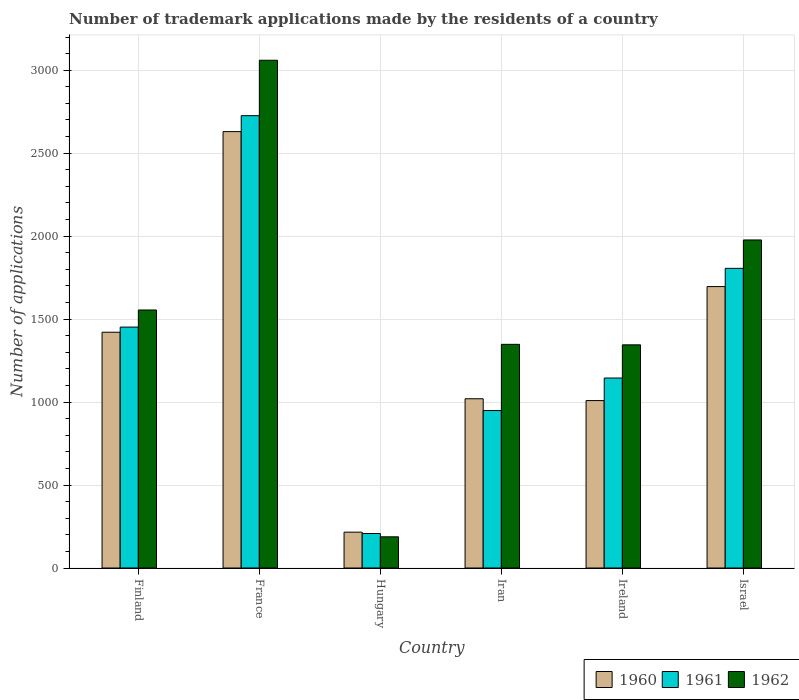How many different coloured bars are there?
Your answer should be compact. 3. Are the number of bars per tick equal to the number of legend labels?
Your answer should be compact. Yes. Are the number of bars on each tick of the X-axis equal?
Offer a terse response. Yes. How many bars are there on the 6th tick from the left?
Provide a short and direct response. 3. What is the label of the 3rd group of bars from the left?
Provide a succinct answer. Hungary. What is the number of trademark applications made by the residents in 1960 in France?
Your response must be concise. 2630. Across all countries, what is the maximum number of trademark applications made by the residents in 1962?
Offer a terse response. 3060. Across all countries, what is the minimum number of trademark applications made by the residents in 1960?
Provide a succinct answer. 216. In which country was the number of trademark applications made by the residents in 1962 minimum?
Your answer should be very brief. Hungary. What is the total number of trademark applications made by the residents in 1960 in the graph?
Your answer should be compact. 7992. What is the difference between the number of trademark applications made by the residents in 1962 in France and that in Ireland?
Offer a terse response. 1715. What is the difference between the number of trademark applications made by the residents in 1961 in Ireland and the number of trademark applications made by the residents in 1962 in Hungary?
Provide a short and direct response. 957. What is the average number of trademark applications made by the residents in 1962 per country?
Provide a succinct answer. 1578.83. What is the difference between the number of trademark applications made by the residents of/in 1960 and number of trademark applications made by the residents of/in 1962 in Ireland?
Ensure brevity in your answer.  -336. In how many countries, is the number of trademark applications made by the residents in 1960 greater than 800?
Your answer should be compact. 5. What is the ratio of the number of trademark applications made by the residents in 1961 in France to that in Iran?
Your answer should be very brief. 2.87. Is the difference between the number of trademark applications made by the residents in 1960 in France and Israel greater than the difference between the number of trademark applications made by the residents in 1962 in France and Israel?
Provide a succinct answer. No. What is the difference between the highest and the second highest number of trademark applications made by the residents in 1962?
Provide a succinct answer. 422. What is the difference between the highest and the lowest number of trademark applications made by the residents in 1962?
Provide a short and direct response. 2872. Is the sum of the number of trademark applications made by the residents in 1962 in Finland and Iran greater than the maximum number of trademark applications made by the residents in 1961 across all countries?
Keep it short and to the point. Yes. What does the 1st bar from the right in France represents?
Ensure brevity in your answer.  1962. How many countries are there in the graph?
Provide a short and direct response. 6. What is the title of the graph?
Your response must be concise. Number of trademark applications made by the residents of a country. Does "1980" appear as one of the legend labels in the graph?
Provide a short and direct response. No. What is the label or title of the Y-axis?
Make the answer very short. Number of applications. What is the Number of applications in 1960 in Finland?
Your answer should be compact. 1421. What is the Number of applications in 1961 in Finland?
Your response must be concise. 1452. What is the Number of applications of 1962 in Finland?
Provide a succinct answer. 1555. What is the Number of applications in 1960 in France?
Make the answer very short. 2630. What is the Number of applications in 1961 in France?
Provide a succinct answer. 2726. What is the Number of applications in 1962 in France?
Ensure brevity in your answer.  3060. What is the Number of applications of 1960 in Hungary?
Provide a short and direct response. 216. What is the Number of applications in 1961 in Hungary?
Offer a terse response. 208. What is the Number of applications of 1962 in Hungary?
Keep it short and to the point. 188. What is the Number of applications in 1960 in Iran?
Provide a short and direct response. 1020. What is the Number of applications of 1961 in Iran?
Your answer should be very brief. 949. What is the Number of applications of 1962 in Iran?
Keep it short and to the point. 1348. What is the Number of applications of 1960 in Ireland?
Offer a very short reply. 1009. What is the Number of applications of 1961 in Ireland?
Offer a terse response. 1145. What is the Number of applications of 1962 in Ireland?
Make the answer very short. 1345. What is the Number of applications of 1960 in Israel?
Offer a very short reply. 1696. What is the Number of applications of 1961 in Israel?
Your answer should be compact. 1806. What is the Number of applications in 1962 in Israel?
Provide a short and direct response. 1977. Across all countries, what is the maximum Number of applications in 1960?
Your answer should be compact. 2630. Across all countries, what is the maximum Number of applications in 1961?
Give a very brief answer. 2726. Across all countries, what is the maximum Number of applications of 1962?
Your answer should be compact. 3060. Across all countries, what is the minimum Number of applications in 1960?
Make the answer very short. 216. Across all countries, what is the minimum Number of applications of 1961?
Offer a terse response. 208. Across all countries, what is the minimum Number of applications in 1962?
Give a very brief answer. 188. What is the total Number of applications in 1960 in the graph?
Make the answer very short. 7992. What is the total Number of applications of 1961 in the graph?
Offer a very short reply. 8286. What is the total Number of applications in 1962 in the graph?
Ensure brevity in your answer.  9473. What is the difference between the Number of applications of 1960 in Finland and that in France?
Offer a terse response. -1209. What is the difference between the Number of applications of 1961 in Finland and that in France?
Provide a succinct answer. -1274. What is the difference between the Number of applications of 1962 in Finland and that in France?
Keep it short and to the point. -1505. What is the difference between the Number of applications of 1960 in Finland and that in Hungary?
Keep it short and to the point. 1205. What is the difference between the Number of applications of 1961 in Finland and that in Hungary?
Give a very brief answer. 1244. What is the difference between the Number of applications of 1962 in Finland and that in Hungary?
Offer a very short reply. 1367. What is the difference between the Number of applications of 1960 in Finland and that in Iran?
Ensure brevity in your answer.  401. What is the difference between the Number of applications of 1961 in Finland and that in Iran?
Your answer should be very brief. 503. What is the difference between the Number of applications in 1962 in Finland and that in Iran?
Offer a terse response. 207. What is the difference between the Number of applications of 1960 in Finland and that in Ireland?
Make the answer very short. 412. What is the difference between the Number of applications in 1961 in Finland and that in Ireland?
Ensure brevity in your answer.  307. What is the difference between the Number of applications of 1962 in Finland and that in Ireland?
Keep it short and to the point. 210. What is the difference between the Number of applications of 1960 in Finland and that in Israel?
Provide a succinct answer. -275. What is the difference between the Number of applications in 1961 in Finland and that in Israel?
Your answer should be very brief. -354. What is the difference between the Number of applications of 1962 in Finland and that in Israel?
Your response must be concise. -422. What is the difference between the Number of applications in 1960 in France and that in Hungary?
Keep it short and to the point. 2414. What is the difference between the Number of applications in 1961 in France and that in Hungary?
Offer a terse response. 2518. What is the difference between the Number of applications in 1962 in France and that in Hungary?
Keep it short and to the point. 2872. What is the difference between the Number of applications in 1960 in France and that in Iran?
Give a very brief answer. 1610. What is the difference between the Number of applications of 1961 in France and that in Iran?
Provide a succinct answer. 1777. What is the difference between the Number of applications of 1962 in France and that in Iran?
Keep it short and to the point. 1712. What is the difference between the Number of applications of 1960 in France and that in Ireland?
Your response must be concise. 1621. What is the difference between the Number of applications of 1961 in France and that in Ireland?
Give a very brief answer. 1581. What is the difference between the Number of applications in 1962 in France and that in Ireland?
Provide a succinct answer. 1715. What is the difference between the Number of applications of 1960 in France and that in Israel?
Ensure brevity in your answer.  934. What is the difference between the Number of applications of 1961 in France and that in Israel?
Offer a terse response. 920. What is the difference between the Number of applications of 1962 in France and that in Israel?
Provide a short and direct response. 1083. What is the difference between the Number of applications in 1960 in Hungary and that in Iran?
Your answer should be compact. -804. What is the difference between the Number of applications of 1961 in Hungary and that in Iran?
Offer a terse response. -741. What is the difference between the Number of applications of 1962 in Hungary and that in Iran?
Your answer should be very brief. -1160. What is the difference between the Number of applications in 1960 in Hungary and that in Ireland?
Make the answer very short. -793. What is the difference between the Number of applications of 1961 in Hungary and that in Ireland?
Give a very brief answer. -937. What is the difference between the Number of applications in 1962 in Hungary and that in Ireland?
Provide a succinct answer. -1157. What is the difference between the Number of applications of 1960 in Hungary and that in Israel?
Give a very brief answer. -1480. What is the difference between the Number of applications of 1961 in Hungary and that in Israel?
Provide a short and direct response. -1598. What is the difference between the Number of applications in 1962 in Hungary and that in Israel?
Make the answer very short. -1789. What is the difference between the Number of applications of 1960 in Iran and that in Ireland?
Your response must be concise. 11. What is the difference between the Number of applications in 1961 in Iran and that in Ireland?
Offer a very short reply. -196. What is the difference between the Number of applications in 1960 in Iran and that in Israel?
Offer a terse response. -676. What is the difference between the Number of applications in 1961 in Iran and that in Israel?
Your answer should be compact. -857. What is the difference between the Number of applications of 1962 in Iran and that in Israel?
Your answer should be very brief. -629. What is the difference between the Number of applications in 1960 in Ireland and that in Israel?
Your answer should be compact. -687. What is the difference between the Number of applications of 1961 in Ireland and that in Israel?
Provide a short and direct response. -661. What is the difference between the Number of applications in 1962 in Ireland and that in Israel?
Give a very brief answer. -632. What is the difference between the Number of applications of 1960 in Finland and the Number of applications of 1961 in France?
Keep it short and to the point. -1305. What is the difference between the Number of applications of 1960 in Finland and the Number of applications of 1962 in France?
Offer a terse response. -1639. What is the difference between the Number of applications in 1961 in Finland and the Number of applications in 1962 in France?
Offer a terse response. -1608. What is the difference between the Number of applications of 1960 in Finland and the Number of applications of 1961 in Hungary?
Make the answer very short. 1213. What is the difference between the Number of applications in 1960 in Finland and the Number of applications in 1962 in Hungary?
Offer a terse response. 1233. What is the difference between the Number of applications in 1961 in Finland and the Number of applications in 1962 in Hungary?
Provide a short and direct response. 1264. What is the difference between the Number of applications in 1960 in Finland and the Number of applications in 1961 in Iran?
Provide a succinct answer. 472. What is the difference between the Number of applications in 1961 in Finland and the Number of applications in 1962 in Iran?
Give a very brief answer. 104. What is the difference between the Number of applications of 1960 in Finland and the Number of applications of 1961 in Ireland?
Your answer should be compact. 276. What is the difference between the Number of applications in 1961 in Finland and the Number of applications in 1962 in Ireland?
Offer a very short reply. 107. What is the difference between the Number of applications in 1960 in Finland and the Number of applications in 1961 in Israel?
Offer a terse response. -385. What is the difference between the Number of applications in 1960 in Finland and the Number of applications in 1962 in Israel?
Give a very brief answer. -556. What is the difference between the Number of applications of 1961 in Finland and the Number of applications of 1962 in Israel?
Offer a very short reply. -525. What is the difference between the Number of applications in 1960 in France and the Number of applications in 1961 in Hungary?
Offer a terse response. 2422. What is the difference between the Number of applications of 1960 in France and the Number of applications of 1962 in Hungary?
Offer a terse response. 2442. What is the difference between the Number of applications in 1961 in France and the Number of applications in 1962 in Hungary?
Provide a short and direct response. 2538. What is the difference between the Number of applications of 1960 in France and the Number of applications of 1961 in Iran?
Make the answer very short. 1681. What is the difference between the Number of applications in 1960 in France and the Number of applications in 1962 in Iran?
Ensure brevity in your answer.  1282. What is the difference between the Number of applications in 1961 in France and the Number of applications in 1962 in Iran?
Your answer should be very brief. 1378. What is the difference between the Number of applications of 1960 in France and the Number of applications of 1961 in Ireland?
Your response must be concise. 1485. What is the difference between the Number of applications in 1960 in France and the Number of applications in 1962 in Ireland?
Your response must be concise. 1285. What is the difference between the Number of applications in 1961 in France and the Number of applications in 1962 in Ireland?
Provide a succinct answer. 1381. What is the difference between the Number of applications in 1960 in France and the Number of applications in 1961 in Israel?
Provide a succinct answer. 824. What is the difference between the Number of applications of 1960 in France and the Number of applications of 1962 in Israel?
Your answer should be very brief. 653. What is the difference between the Number of applications in 1961 in France and the Number of applications in 1962 in Israel?
Give a very brief answer. 749. What is the difference between the Number of applications in 1960 in Hungary and the Number of applications in 1961 in Iran?
Offer a terse response. -733. What is the difference between the Number of applications in 1960 in Hungary and the Number of applications in 1962 in Iran?
Keep it short and to the point. -1132. What is the difference between the Number of applications in 1961 in Hungary and the Number of applications in 1962 in Iran?
Keep it short and to the point. -1140. What is the difference between the Number of applications in 1960 in Hungary and the Number of applications in 1961 in Ireland?
Provide a succinct answer. -929. What is the difference between the Number of applications of 1960 in Hungary and the Number of applications of 1962 in Ireland?
Offer a terse response. -1129. What is the difference between the Number of applications of 1961 in Hungary and the Number of applications of 1962 in Ireland?
Offer a very short reply. -1137. What is the difference between the Number of applications of 1960 in Hungary and the Number of applications of 1961 in Israel?
Make the answer very short. -1590. What is the difference between the Number of applications of 1960 in Hungary and the Number of applications of 1962 in Israel?
Provide a succinct answer. -1761. What is the difference between the Number of applications of 1961 in Hungary and the Number of applications of 1962 in Israel?
Make the answer very short. -1769. What is the difference between the Number of applications in 1960 in Iran and the Number of applications in 1961 in Ireland?
Provide a succinct answer. -125. What is the difference between the Number of applications in 1960 in Iran and the Number of applications in 1962 in Ireland?
Your answer should be very brief. -325. What is the difference between the Number of applications in 1961 in Iran and the Number of applications in 1962 in Ireland?
Provide a succinct answer. -396. What is the difference between the Number of applications in 1960 in Iran and the Number of applications in 1961 in Israel?
Give a very brief answer. -786. What is the difference between the Number of applications in 1960 in Iran and the Number of applications in 1962 in Israel?
Make the answer very short. -957. What is the difference between the Number of applications of 1961 in Iran and the Number of applications of 1962 in Israel?
Offer a very short reply. -1028. What is the difference between the Number of applications in 1960 in Ireland and the Number of applications in 1961 in Israel?
Your answer should be compact. -797. What is the difference between the Number of applications of 1960 in Ireland and the Number of applications of 1962 in Israel?
Provide a short and direct response. -968. What is the difference between the Number of applications in 1961 in Ireland and the Number of applications in 1962 in Israel?
Provide a short and direct response. -832. What is the average Number of applications in 1960 per country?
Keep it short and to the point. 1332. What is the average Number of applications of 1961 per country?
Provide a short and direct response. 1381. What is the average Number of applications of 1962 per country?
Provide a short and direct response. 1578.83. What is the difference between the Number of applications of 1960 and Number of applications of 1961 in Finland?
Keep it short and to the point. -31. What is the difference between the Number of applications in 1960 and Number of applications in 1962 in Finland?
Offer a terse response. -134. What is the difference between the Number of applications of 1961 and Number of applications of 1962 in Finland?
Offer a terse response. -103. What is the difference between the Number of applications in 1960 and Number of applications in 1961 in France?
Your response must be concise. -96. What is the difference between the Number of applications in 1960 and Number of applications in 1962 in France?
Offer a terse response. -430. What is the difference between the Number of applications of 1961 and Number of applications of 1962 in France?
Your answer should be compact. -334. What is the difference between the Number of applications in 1960 and Number of applications in 1961 in Hungary?
Make the answer very short. 8. What is the difference between the Number of applications in 1960 and Number of applications in 1961 in Iran?
Provide a short and direct response. 71. What is the difference between the Number of applications in 1960 and Number of applications in 1962 in Iran?
Your response must be concise. -328. What is the difference between the Number of applications in 1961 and Number of applications in 1962 in Iran?
Give a very brief answer. -399. What is the difference between the Number of applications in 1960 and Number of applications in 1961 in Ireland?
Make the answer very short. -136. What is the difference between the Number of applications in 1960 and Number of applications in 1962 in Ireland?
Give a very brief answer. -336. What is the difference between the Number of applications of 1961 and Number of applications of 1962 in Ireland?
Your response must be concise. -200. What is the difference between the Number of applications of 1960 and Number of applications of 1961 in Israel?
Make the answer very short. -110. What is the difference between the Number of applications of 1960 and Number of applications of 1962 in Israel?
Provide a succinct answer. -281. What is the difference between the Number of applications in 1961 and Number of applications in 1962 in Israel?
Make the answer very short. -171. What is the ratio of the Number of applications in 1960 in Finland to that in France?
Ensure brevity in your answer.  0.54. What is the ratio of the Number of applications in 1961 in Finland to that in France?
Provide a succinct answer. 0.53. What is the ratio of the Number of applications in 1962 in Finland to that in France?
Make the answer very short. 0.51. What is the ratio of the Number of applications in 1960 in Finland to that in Hungary?
Your response must be concise. 6.58. What is the ratio of the Number of applications in 1961 in Finland to that in Hungary?
Ensure brevity in your answer.  6.98. What is the ratio of the Number of applications of 1962 in Finland to that in Hungary?
Keep it short and to the point. 8.27. What is the ratio of the Number of applications in 1960 in Finland to that in Iran?
Make the answer very short. 1.39. What is the ratio of the Number of applications in 1961 in Finland to that in Iran?
Provide a short and direct response. 1.53. What is the ratio of the Number of applications in 1962 in Finland to that in Iran?
Your answer should be compact. 1.15. What is the ratio of the Number of applications in 1960 in Finland to that in Ireland?
Offer a very short reply. 1.41. What is the ratio of the Number of applications in 1961 in Finland to that in Ireland?
Give a very brief answer. 1.27. What is the ratio of the Number of applications in 1962 in Finland to that in Ireland?
Give a very brief answer. 1.16. What is the ratio of the Number of applications of 1960 in Finland to that in Israel?
Your answer should be very brief. 0.84. What is the ratio of the Number of applications in 1961 in Finland to that in Israel?
Provide a succinct answer. 0.8. What is the ratio of the Number of applications of 1962 in Finland to that in Israel?
Your response must be concise. 0.79. What is the ratio of the Number of applications in 1960 in France to that in Hungary?
Your answer should be compact. 12.18. What is the ratio of the Number of applications of 1961 in France to that in Hungary?
Provide a short and direct response. 13.11. What is the ratio of the Number of applications in 1962 in France to that in Hungary?
Your answer should be very brief. 16.28. What is the ratio of the Number of applications in 1960 in France to that in Iran?
Offer a very short reply. 2.58. What is the ratio of the Number of applications in 1961 in France to that in Iran?
Your answer should be very brief. 2.87. What is the ratio of the Number of applications in 1962 in France to that in Iran?
Provide a short and direct response. 2.27. What is the ratio of the Number of applications in 1960 in France to that in Ireland?
Give a very brief answer. 2.61. What is the ratio of the Number of applications of 1961 in France to that in Ireland?
Offer a very short reply. 2.38. What is the ratio of the Number of applications in 1962 in France to that in Ireland?
Provide a succinct answer. 2.28. What is the ratio of the Number of applications of 1960 in France to that in Israel?
Ensure brevity in your answer.  1.55. What is the ratio of the Number of applications of 1961 in France to that in Israel?
Provide a short and direct response. 1.51. What is the ratio of the Number of applications of 1962 in France to that in Israel?
Make the answer very short. 1.55. What is the ratio of the Number of applications in 1960 in Hungary to that in Iran?
Provide a short and direct response. 0.21. What is the ratio of the Number of applications in 1961 in Hungary to that in Iran?
Ensure brevity in your answer.  0.22. What is the ratio of the Number of applications in 1962 in Hungary to that in Iran?
Provide a succinct answer. 0.14. What is the ratio of the Number of applications in 1960 in Hungary to that in Ireland?
Make the answer very short. 0.21. What is the ratio of the Number of applications in 1961 in Hungary to that in Ireland?
Provide a short and direct response. 0.18. What is the ratio of the Number of applications of 1962 in Hungary to that in Ireland?
Your response must be concise. 0.14. What is the ratio of the Number of applications of 1960 in Hungary to that in Israel?
Offer a very short reply. 0.13. What is the ratio of the Number of applications of 1961 in Hungary to that in Israel?
Your answer should be compact. 0.12. What is the ratio of the Number of applications in 1962 in Hungary to that in Israel?
Ensure brevity in your answer.  0.1. What is the ratio of the Number of applications in 1960 in Iran to that in Ireland?
Provide a succinct answer. 1.01. What is the ratio of the Number of applications in 1961 in Iran to that in Ireland?
Your response must be concise. 0.83. What is the ratio of the Number of applications of 1962 in Iran to that in Ireland?
Your response must be concise. 1. What is the ratio of the Number of applications of 1960 in Iran to that in Israel?
Give a very brief answer. 0.6. What is the ratio of the Number of applications in 1961 in Iran to that in Israel?
Make the answer very short. 0.53. What is the ratio of the Number of applications of 1962 in Iran to that in Israel?
Your response must be concise. 0.68. What is the ratio of the Number of applications in 1960 in Ireland to that in Israel?
Keep it short and to the point. 0.59. What is the ratio of the Number of applications in 1961 in Ireland to that in Israel?
Offer a very short reply. 0.63. What is the ratio of the Number of applications in 1962 in Ireland to that in Israel?
Make the answer very short. 0.68. What is the difference between the highest and the second highest Number of applications in 1960?
Keep it short and to the point. 934. What is the difference between the highest and the second highest Number of applications of 1961?
Your response must be concise. 920. What is the difference between the highest and the second highest Number of applications in 1962?
Offer a very short reply. 1083. What is the difference between the highest and the lowest Number of applications in 1960?
Your answer should be compact. 2414. What is the difference between the highest and the lowest Number of applications of 1961?
Keep it short and to the point. 2518. What is the difference between the highest and the lowest Number of applications of 1962?
Offer a very short reply. 2872. 